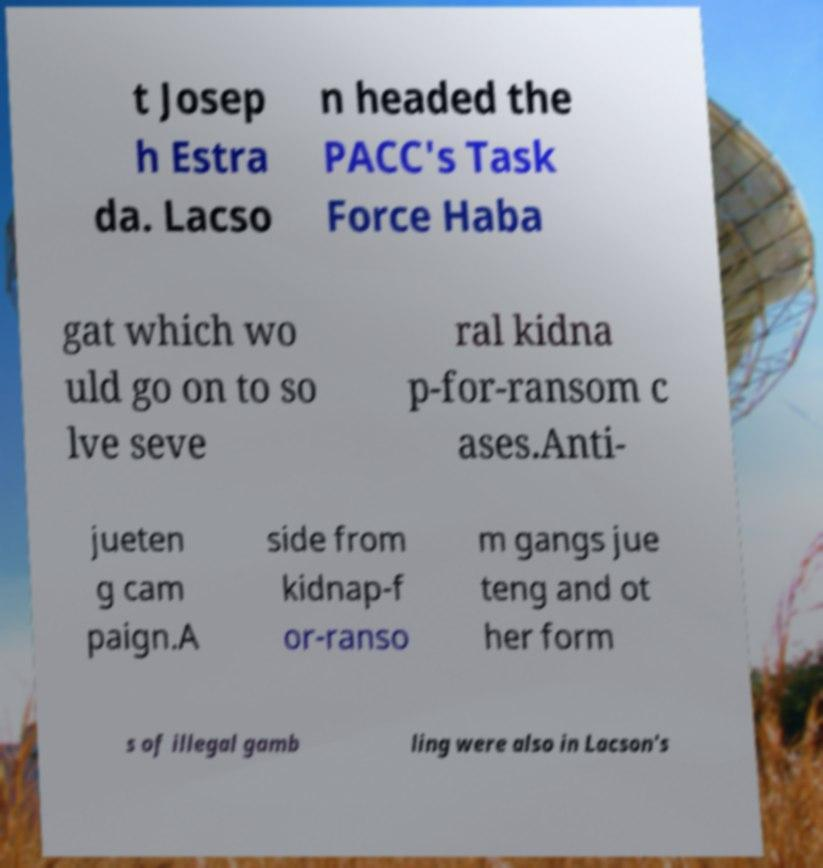Can you accurately transcribe the text from the provided image for me? t Josep h Estra da. Lacso n headed the PACC's Task Force Haba gat which wo uld go on to so lve seve ral kidna p-for-ransom c ases.Anti- jueten g cam paign.A side from kidnap-f or-ranso m gangs jue teng and ot her form s of illegal gamb ling were also in Lacson's 